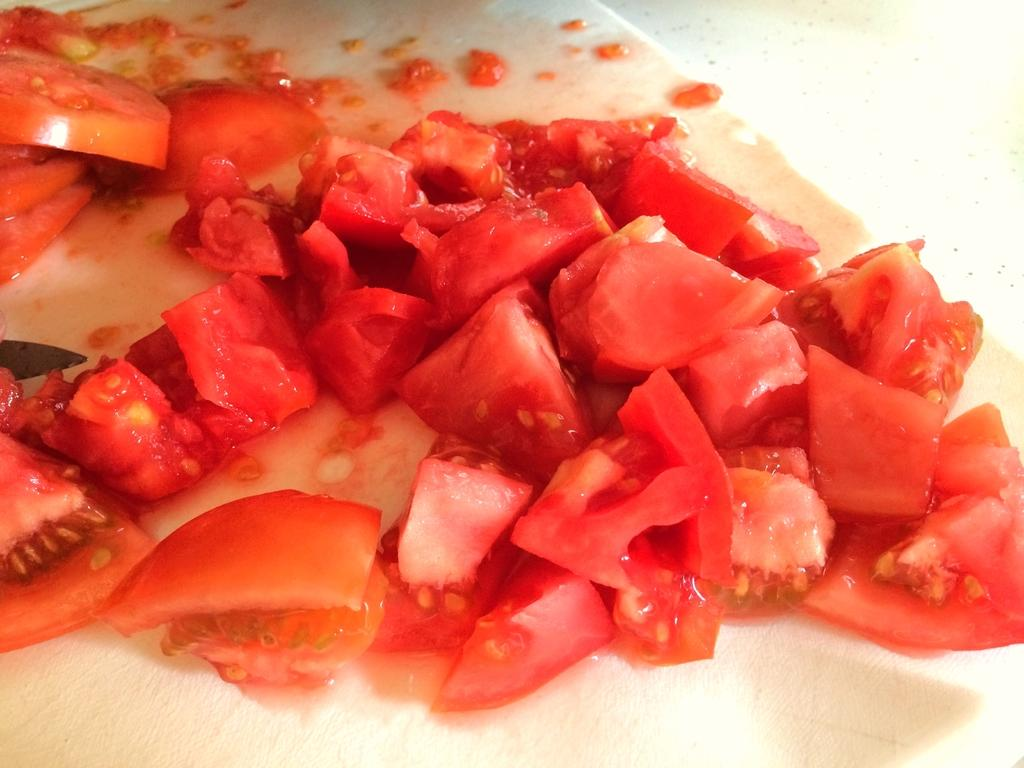What type of food can be seen in the image? There are chopped tomatoes in the image. What is the chopped tomatoes placed on? The chopped tomatoes are on a white-colored thing. What type of lead can be seen in the image? There is no lead present in the image; it features chopped tomatoes on a white-colored thing. What type of teeth can be seen in the image? There are no teeth visible in the image, as it features chopped tomatoes on a white-colored thing. 